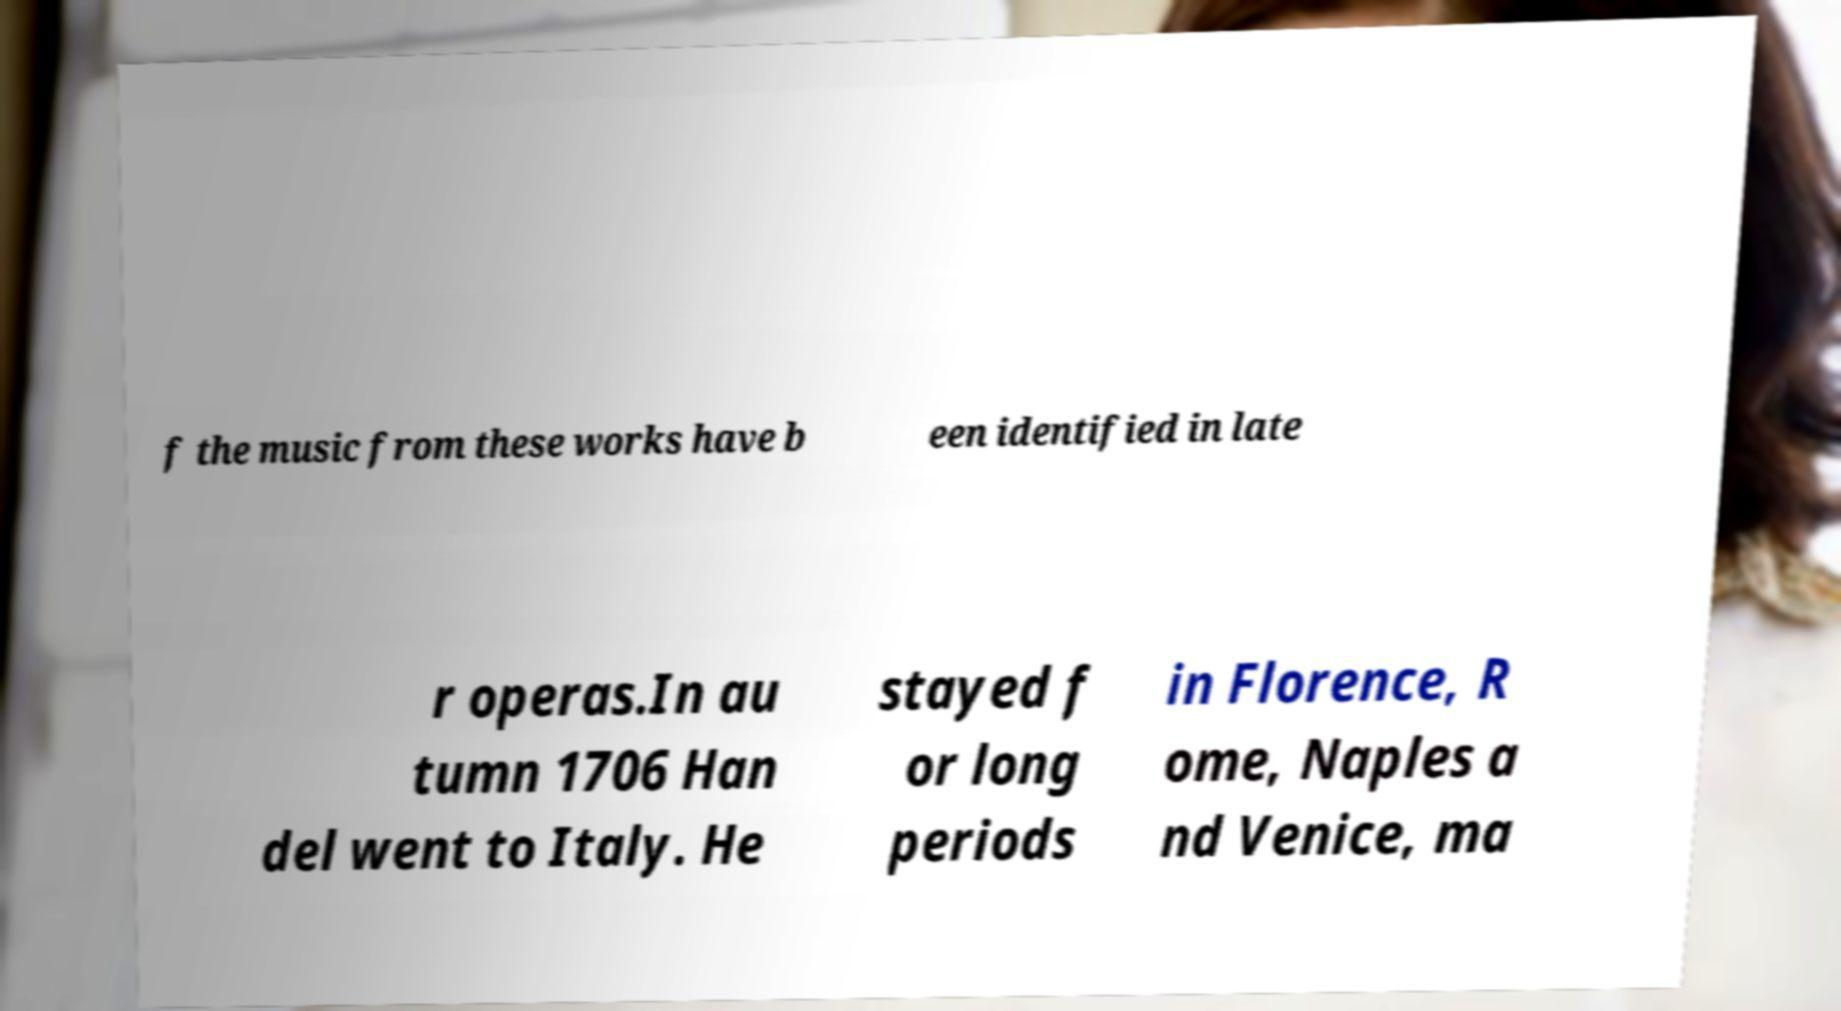Can you accurately transcribe the text from the provided image for me? f the music from these works have b een identified in late r operas.In au tumn 1706 Han del went to Italy. He stayed f or long periods in Florence, R ome, Naples a nd Venice, ma 